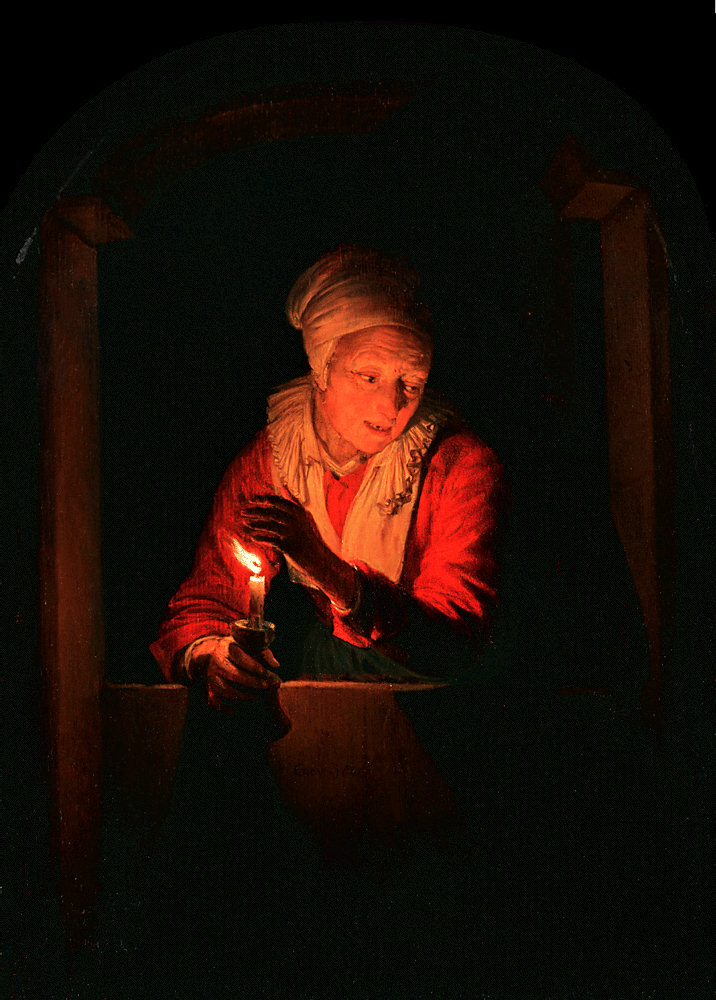What's happening in the scene? This is a mesmerizing oil painting that embodies the art of realism. At the heart of the painting, an elderly woman is gently illuminated by a lit candle she holds. Her attire includes a modest white headscarf and a warm red shawl, hinting at simplicity yet depth. The scene is framed within an arched window, which is the sole source of light, casting the woman in a soft, captivating glow against a starkly dark background. Despite the enveloping darkness, the warm light and the woman's serene presence evoke a sense of comfort and solace. The color palette of red, white, and black highlights the mood and atmosphere, while the artist's excellent use of realism captures not only the physical appearance but also the subtle emotions and ambience of the setting. 